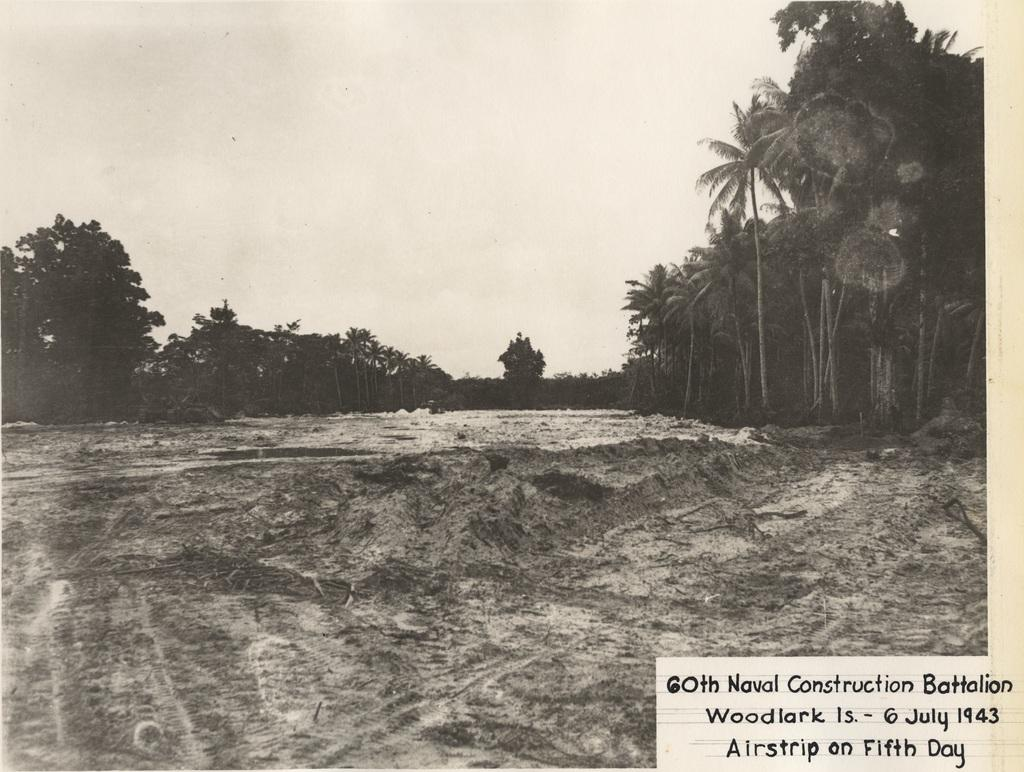What is located in the center of the image? There is ground in the center of the image. What type of vegetation can be seen on the right side of the image? Trees are present on the right side of the image. What type of vegetation can be seen on the left side of the image? Trees are present on the left side of the image. What is visible at the top of the image? The sky is visible at the top of the image. What type of pipe is visible in the image? There is no pipe present in the image. What historical event is depicted in the image? There is no historical event depicted in the image; it features ground, trees, and sky. 